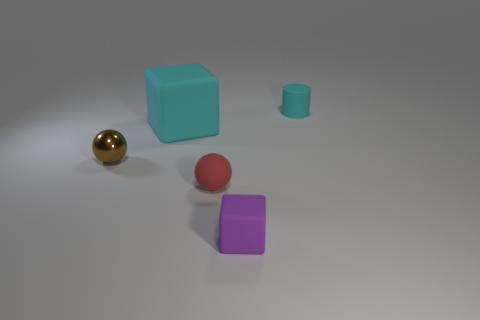Can you tell me the colors of all the objects visible in the image? Certainly! In the image, there are objects with the following colors: cyan (cube), gold (sphere), red (small sphere), and purple (cube). There is also a grey cylindrical object. 